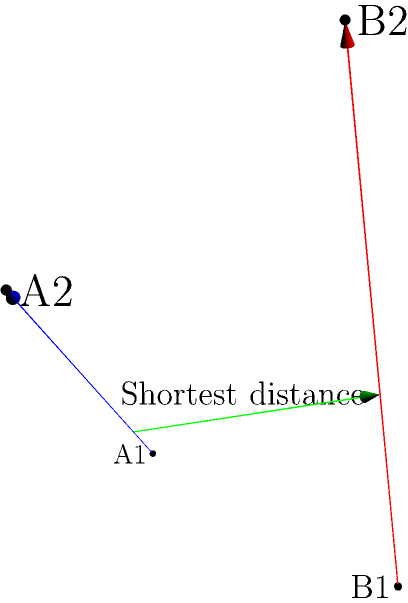In a 3D network diagram representing data transfer paths, two skew lines are given:
Line A: passing through points $A_1(0,0,0)$ and $A_2(3,1,2)$
Line B: passing through points $B_1(1,2,0)$ and $B_2(2,2,3)$

Calculate the shortest distance between these two lines, representing the optimal path for data transfer between the networks. To find the shortest distance between two skew lines, we'll follow these steps:

1) First, we need to express the lines in parametric form:
   Line A: $\mathbf{r_A} = (0,0,0) + t(3,1,2)$
   Line B: $\mathbf{r_B} = (1,2,0) + s(1,0,3)$

2) The direction vectors of the lines are:
   $\mathbf{a} = (3,1,2)$ and $\mathbf{b} = (1,0,3)$

3) Calculate the normal vector to both lines:
   $\mathbf{n} = \mathbf{a} \times \mathbf{b} = (1,-9,1)$

4) The vector equation of the plane containing line A and parallel to n is:
   $((x,y,z) - (0,0,0)) \cdot (1,-9,1) = 0$
   $x - 9y + z = 0$

5) Substitute the parametric equation of line B into this plane equation:
   $(1+s) - 9(2) + (3s) = 0$
   $1 + s - 18 + 3s = 0$
   $4s = 17$
   $s = \frac{17}{4}$

6) The point on line B closest to line A is:
   $Q = (1,2,0) + \frac{17}{4}(1,0,3) = (\frac{21}{4}, 2, \frac{51}{4})$

7) Substitute this point into the equation of the plane perpendicular to line A:
   $((x,y,z) - (\frac{21}{4}, 2, \frac{51}{4})) \cdot (3,1,2) = 0$

8) Solve this equation with the parametric equation of line A to find t:
   $t = \frac{3}{7}$

9) The point on line A closest to line B is:
   $P = (0,0,0) + \frac{3}{7}(3,1,2) = (\frac{9}{7}, \frac{3}{7}, \frac{6}{7})$

10) The shortest distance is the magnitude of the vector PQ:
    $\overrightarrow{PQ} = (\frac{21}{4} - \frac{9}{7}, 2 - \frac{3}{7}, \frac{51}{4} - \frac{6}{7})$
    $= (\frac{39}{28}, \frac{11}{7}, \frac{93}{28})$

11) The shortest distance is:
    $d = \sqrt{(\frac{39}{28})^2 + (\frac{11}{7})^2 + (\frac{93}{28})^2} = \frac{\sqrt{1323}}{14} \approx 2.60$
Answer: $\frac{\sqrt{1323}}{14}$ units 